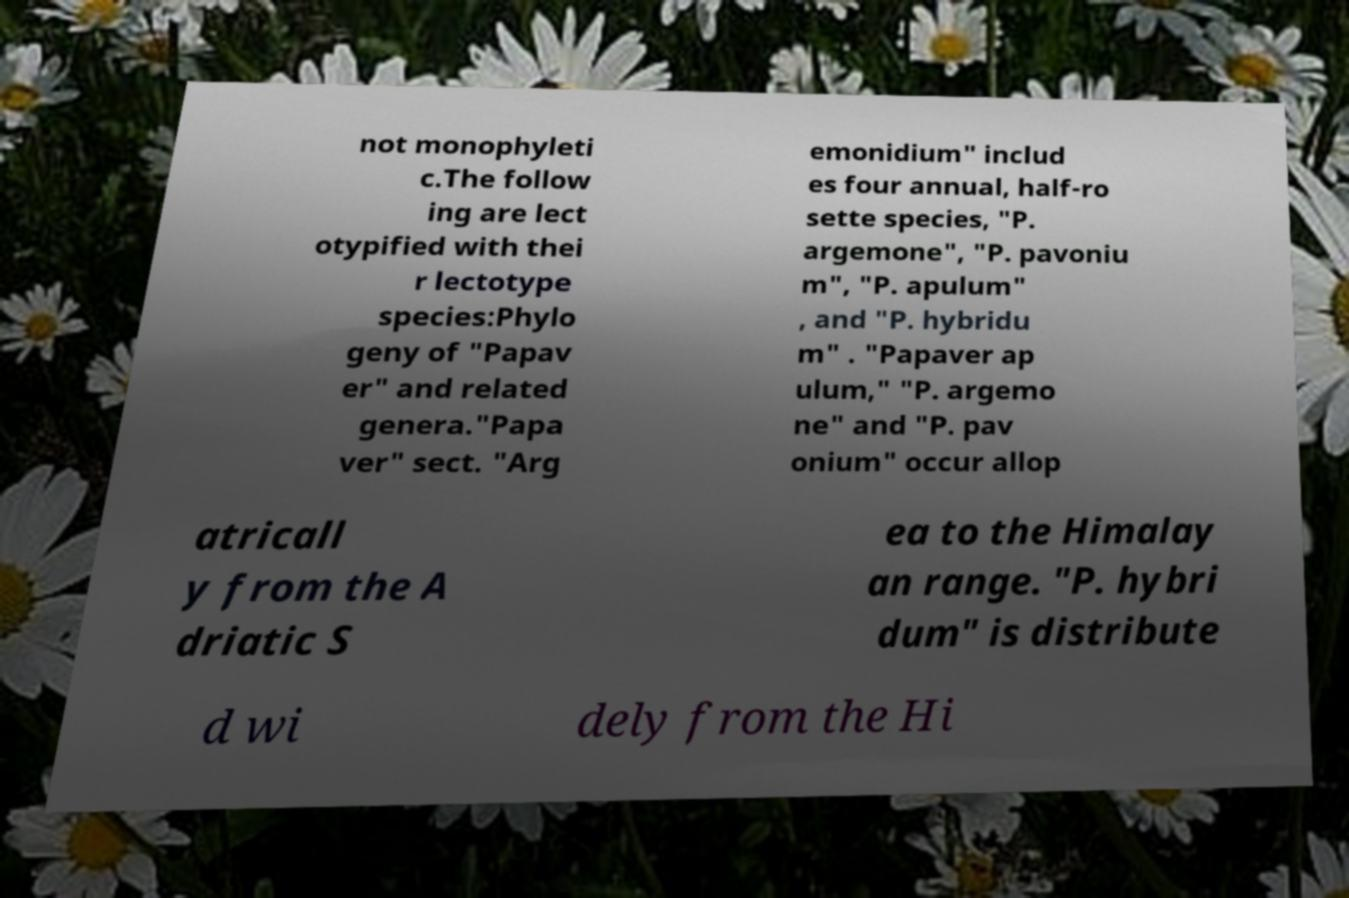There's text embedded in this image that I need extracted. Can you transcribe it verbatim? not monophyleti c.The follow ing are lect otypified with thei r lectotype species:Phylo geny of "Papav er" and related genera."Papa ver" sect. "Arg emonidium" includ es four annual, half-ro sette species, "P. argemone", "P. pavoniu m", "P. apulum" , and "P. hybridu m" . "Papaver ap ulum," "P. argemo ne" and "P. pav onium" occur allop atricall y from the A driatic S ea to the Himalay an range. "P. hybri dum" is distribute d wi dely from the Hi 